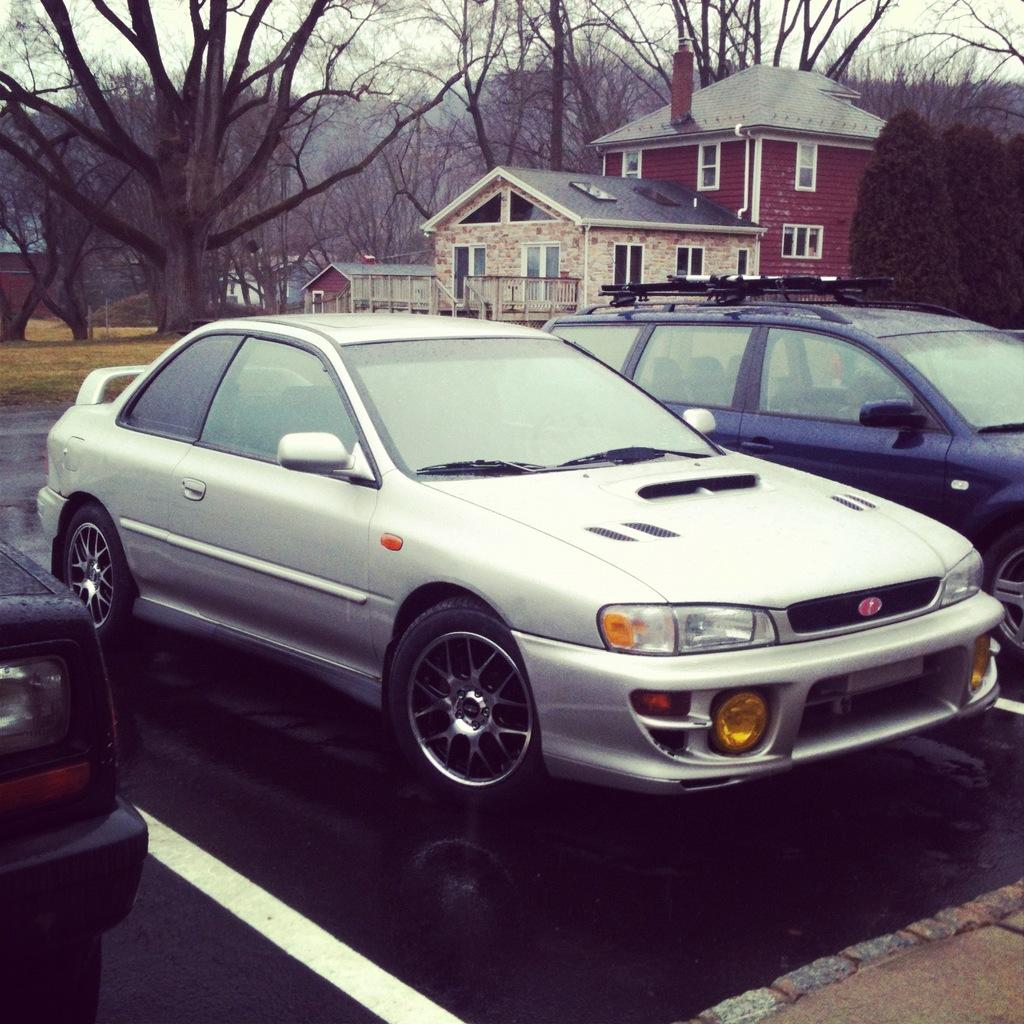What type: What structures are visible in the image? There are buildings in the image. What else can be seen on the ground in the image? Cars are parked in the image. What type of vegetation is present in the image? There are trees in the image. How would you describe the sky in the image? The sky is cloudy in the image. Can you see a cow jumping over the buildings in the image? No, there is no cow present in the image, and it is not jumping over any buildings. 